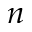<formula> <loc_0><loc_0><loc_500><loc_500>n</formula> 